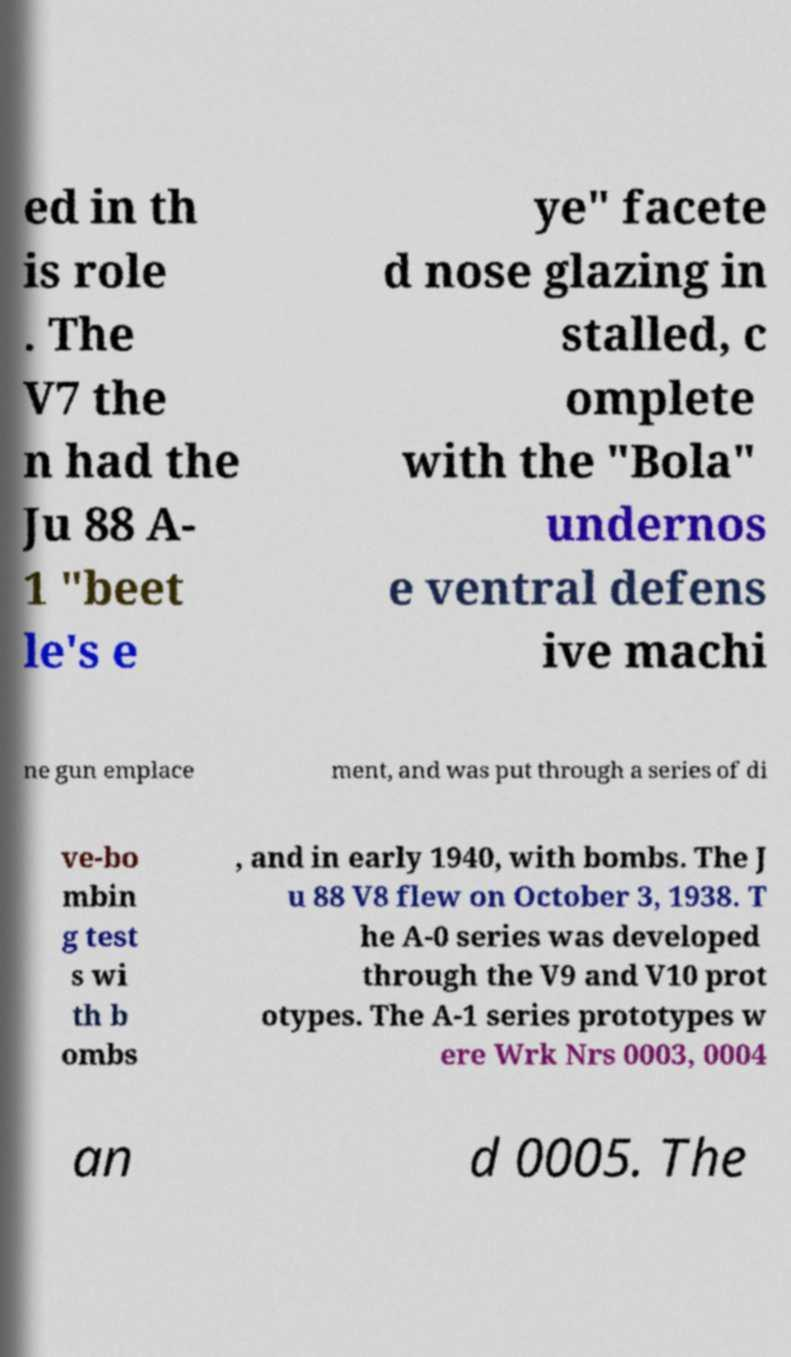Could you extract and type out the text from this image? ed in th is role . The V7 the n had the Ju 88 A- 1 "beet le's e ye" facete d nose glazing in stalled, c omplete with the "Bola" undernos e ventral defens ive machi ne gun emplace ment, and was put through a series of di ve-bo mbin g test s wi th b ombs , and in early 1940, with bombs. The J u 88 V8 flew on October 3, 1938. T he A-0 series was developed through the V9 and V10 prot otypes. The A-1 series prototypes w ere Wrk Nrs 0003, 0004 an d 0005. The 